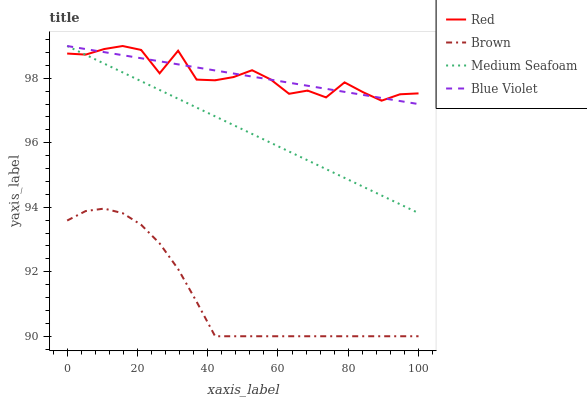Does Brown have the minimum area under the curve?
Answer yes or no. Yes. Does Blue Violet have the maximum area under the curve?
Answer yes or no. Yes. Does Medium Seafoam have the minimum area under the curve?
Answer yes or no. No. Does Medium Seafoam have the maximum area under the curve?
Answer yes or no. No. Is Blue Violet the smoothest?
Answer yes or no. Yes. Is Red the roughest?
Answer yes or no. Yes. Is Brown the smoothest?
Answer yes or no. No. Is Brown the roughest?
Answer yes or no. No. Does Brown have the lowest value?
Answer yes or no. Yes. Does Medium Seafoam have the lowest value?
Answer yes or no. No. Does Red have the highest value?
Answer yes or no. Yes. Does Brown have the highest value?
Answer yes or no. No. Is Brown less than Red?
Answer yes or no. Yes. Is Blue Violet greater than Brown?
Answer yes or no. Yes. Does Red intersect Blue Violet?
Answer yes or no. Yes. Is Red less than Blue Violet?
Answer yes or no. No. Is Red greater than Blue Violet?
Answer yes or no. No. Does Brown intersect Red?
Answer yes or no. No. 